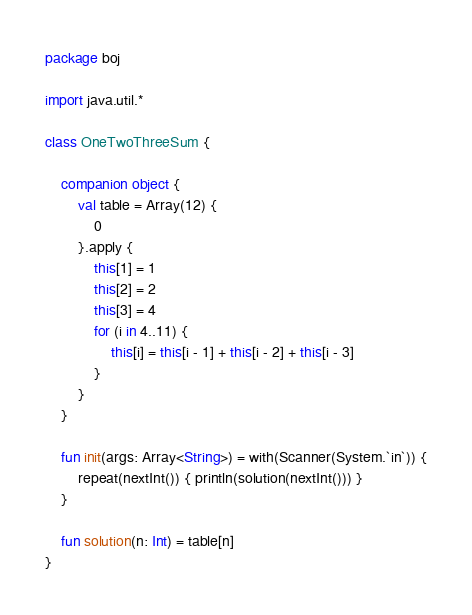Convert code to text. <code><loc_0><loc_0><loc_500><loc_500><_Kotlin_>package boj

import java.util.*

class OneTwoThreeSum {

    companion object {
        val table = Array(12) {
            0
        }.apply {
            this[1] = 1
            this[2] = 2
            this[3] = 4
            for (i in 4..11) {
                this[i] = this[i - 1] + this[i - 2] + this[i - 3]
            }
        }
    }

    fun init(args: Array<String>) = with(Scanner(System.`in`)) {
        repeat(nextInt()) { println(solution(nextInt())) }
    }

    fun solution(n: Int) = table[n]
}
</code> 